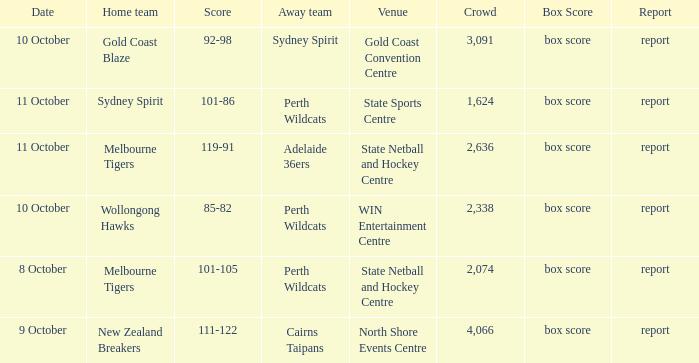What was the number of the crowd when the Wollongong Hawks were the home team? 2338.0. 